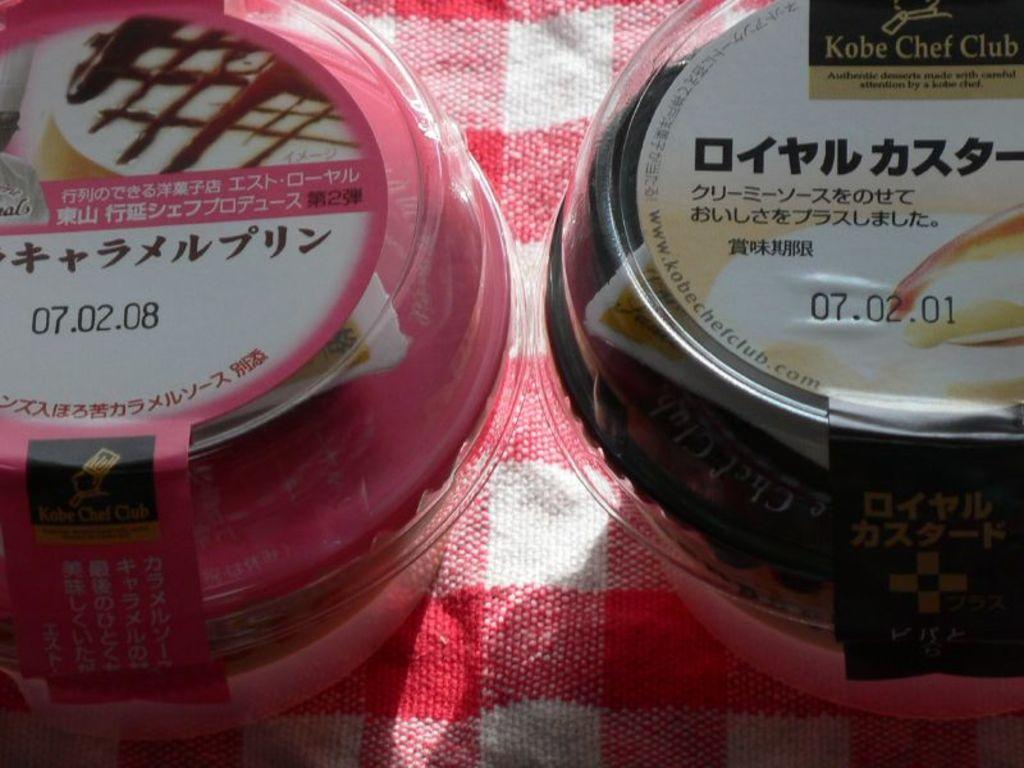Provide a one-sentence caption for the provided image. Two unopened desserts from the Kobe Chef Club and with Japanese writing on them stand next to each other. 